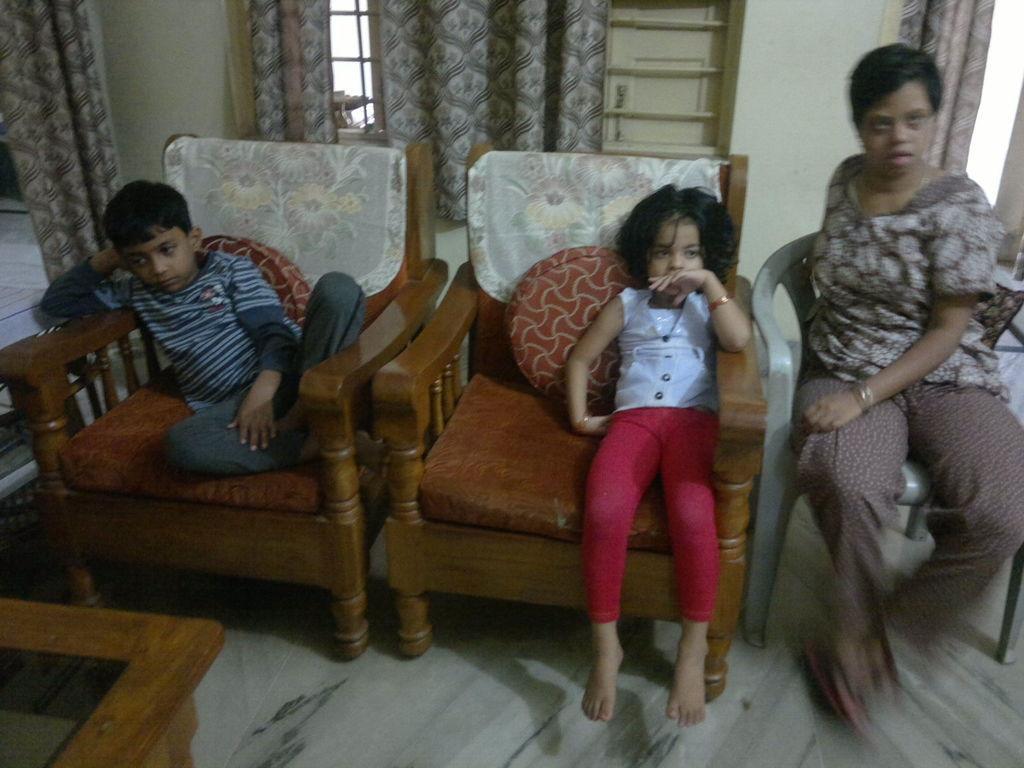Could you give a brief overview of what you see in this image? These 3 persons are sitting on a chair. This is window with curtain. In-front of this boy there is a table. On this chairs there are pillows. 